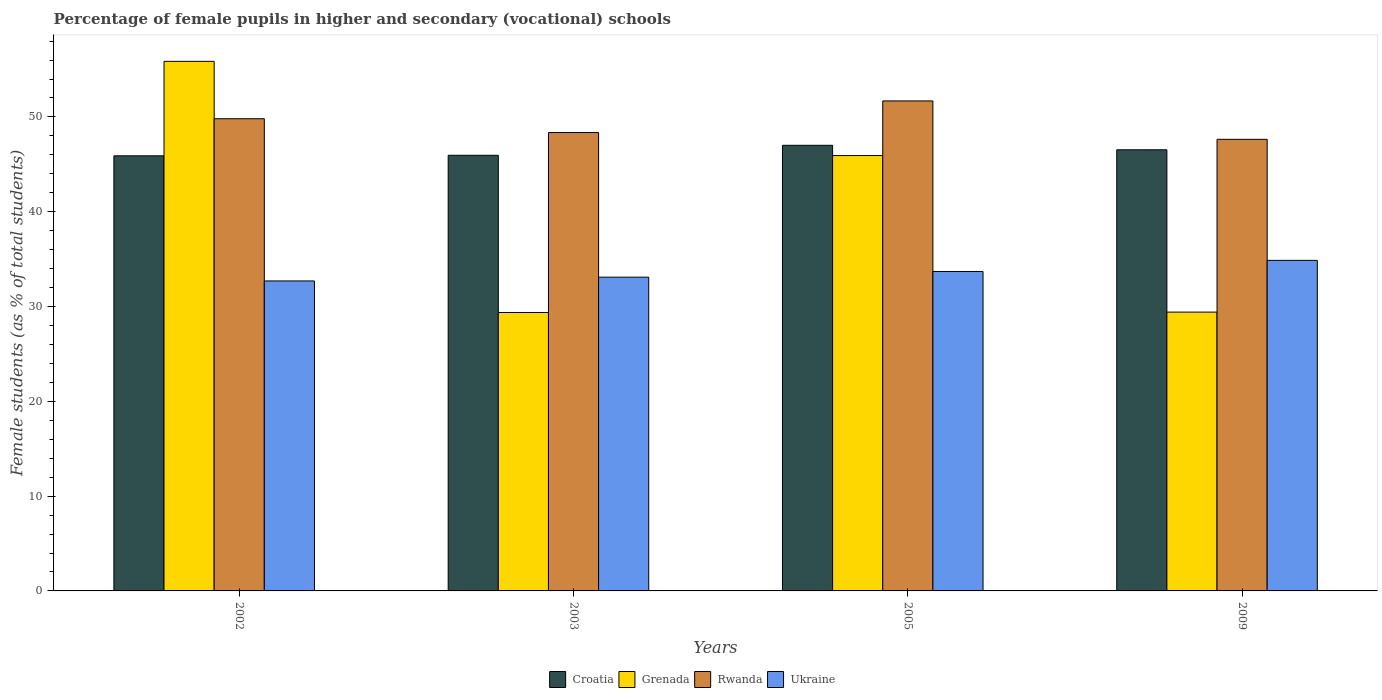How many groups of bars are there?
Provide a succinct answer. 4. Are the number of bars per tick equal to the number of legend labels?
Offer a terse response. Yes. Are the number of bars on each tick of the X-axis equal?
Offer a very short reply. Yes. How many bars are there on the 4th tick from the left?
Your response must be concise. 4. How many bars are there on the 4th tick from the right?
Your answer should be very brief. 4. In how many cases, is the number of bars for a given year not equal to the number of legend labels?
Offer a terse response. 0. What is the percentage of female pupils in higher and secondary schools in Rwanda in 2003?
Offer a very short reply. 48.35. Across all years, what is the maximum percentage of female pupils in higher and secondary schools in Grenada?
Make the answer very short. 55.87. Across all years, what is the minimum percentage of female pupils in higher and secondary schools in Rwanda?
Provide a short and direct response. 47.64. In which year was the percentage of female pupils in higher and secondary schools in Croatia maximum?
Your response must be concise. 2005. In which year was the percentage of female pupils in higher and secondary schools in Grenada minimum?
Provide a succinct answer. 2003. What is the total percentage of female pupils in higher and secondary schools in Croatia in the graph?
Offer a very short reply. 185.4. What is the difference between the percentage of female pupils in higher and secondary schools in Ukraine in 2002 and that in 2009?
Make the answer very short. -2.17. What is the difference between the percentage of female pupils in higher and secondary schools in Grenada in 2003 and the percentage of female pupils in higher and secondary schools in Croatia in 2009?
Provide a short and direct response. -17.16. What is the average percentage of female pupils in higher and secondary schools in Ukraine per year?
Provide a succinct answer. 33.59. In the year 2009, what is the difference between the percentage of female pupils in higher and secondary schools in Rwanda and percentage of female pupils in higher and secondary schools in Grenada?
Provide a short and direct response. 18.23. In how many years, is the percentage of female pupils in higher and secondary schools in Grenada greater than 50 %?
Keep it short and to the point. 1. What is the ratio of the percentage of female pupils in higher and secondary schools in Ukraine in 2003 to that in 2005?
Ensure brevity in your answer.  0.98. What is the difference between the highest and the second highest percentage of female pupils in higher and secondary schools in Grenada?
Provide a succinct answer. 9.94. What is the difference between the highest and the lowest percentage of female pupils in higher and secondary schools in Croatia?
Provide a succinct answer. 1.11. Is it the case that in every year, the sum of the percentage of female pupils in higher and secondary schools in Ukraine and percentage of female pupils in higher and secondary schools in Grenada is greater than the sum of percentage of female pupils in higher and secondary schools in Croatia and percentage of female pupils in higher and secondary schools in Rwanda?
Your answer should be compact. No. What does the 2nd bar from the left in 2005 represents?
Provide a short and direct response. Grenada. What does the 1st bar from the right in 2009 represents?
Give a very brief answer. Ukraine. Does the graph contain any zero values?
Your answer should be compact. No. How many legend labels are there?
Ensure brevity in your answer.  4. What is the title of the graph?
Your response must be concise. Percentage of female pupils in higher and secondary (vocational) schools. Does "Australia" appear as one of the legend labels in the graph?
Offer a very short reply. No. What is the label or title of the X-axis?
Keep it short and to the point. Years. What is the label or title of the Y-axis?
Ensure brevity in your answer.  Female students (as % of total students). What is the Female students (as % of total students) of Croatia in 2002?
Make the answer very short. 45.9. What is the Female students (as % of total students) of Grenada in 2002?
Provide a succinct answer. 55.87. What is the Female students (as % of total students) of Rwanda in 2002?
Offer a very short reply. 49.81. What is the Female students (as % of total students) of Ukraine in 2002?
Ensure brevity in your answer.  32.7. What is the Female students (as % of total students) in Croatia in 2003?
Offer a terse response. 45.96. What is the Female students (as % of total students) in Grenada in 2003?
Provide a succinct answer. 29.37. What is the Female students (as % of total students) of Rwanda in 2003?
Your answer should be compact. 48.35. What is the Female students (as % of total students) in Ukraine in 2003?
Keep it short and to the point. 33.1. What is the Female students (as % of total students) of Croatia in 2005?
Your response must be concise. 47.01. What is the Female students (as % of total students) of Grenada in 2005?
Offer a terse response. 45.93. What is the Female students (as % of total students) of Rwanda in 2005?
Provide a succinct answer. 51.69. What is the Female students (as % of total students) of Ukraine in 2005?
Your answer should be very brief. 33.7. What is the Female students (as % of total students) of Croatia in 2009?
Your answer should be compact. 46.54. What is the Female students (as % of total students) of Grenada in 2009?
Provide a succinct answer. 29.41. What is the Female students (as % of total students) in Rwanda in 2009?
Your answer should be very brief. 47.64. What is the Female students (as % of total students) in Ukraine in 2009?
Provide a succinct answer. 34.87. Across all years, what is the maximum Female students (as % of total students) of Croatia?
Give a very brief answer. 47.01. Across all years, what is the maximum Female students (as % of total students) of Grenada?
Ensure brevity in your answer.  55.87. Across all years, what is the maximum Female students (as % of total students) of Rwanda?
Provide a succinct answer. 51.69. Across all years, what is the maximum Female students (as % of total students) of Ukraine?
Your response must be concise. 34.87. Across all years, what is the minimum Female students (as % of total students) in Croatia?
Offer a terse response. 45.9. Across all years, what is the minimum Female students (as % of total students) in Grenada?
Your answer should be very brief. 29.37. Across all years, what is the minimum Female students (as % of total students) of Rwanda?
Give a very brief answer. 47.64. Across all years, what is the minimum Female students (as % of total students) in Ukraine?
Your answer should be compact. 32.7. What is the total Female students (as % of total students) of Croatia in the graph?
Your answer should be compact. 185.4. What is the total Female students (as % of total students) in Grenada in the graph?
Keep it short and to the point. 160.58. What is the total Female students (as % of total students) in Rwanda in the graph?
Make the answer very short. 197.5. What is the total Female students (as % of total students) in Ukraine in the graph?
Your response must be concise. 134.37. What is the difference between the Female students (as % of total students) of Croatia in 2002 and that in 2003?
Provide a succinct answer. -0.06. What is the difference between the Female students (as % of total students) in Grenada in 2002 and that in 2003?
Provide a succinct answer. 26.49. What is the difference between the Female students (as % of total students) of Rwanda in 2002 and that in 2003?
Provide a short and direct response. 1.46. What is the difference between the Female students (as % of total students) in Ukraine in 2002 and that in 2003?
Ensure brevity in your answer.  -0.4. What is the difference between the Female students (as % of total students) in Croatia in 2002 and that in 2005?
Your answer should be compact. -1.11. What is the difference between the Female students (as % of total students) in Grenada in 2002 and that in 2005?
Give a very brief answer. 9.94. What is the difference between the Female students (as % of total students) of Rwanda in 2002 and that in 2005?
Provide a succinct answer. -1.88. What is the difference between the Female students (as % of total students) in Ukraine in 2002 and that in 2005?
Offer a terse response. -1. What is the difference between the Female students (as % of total students) of Croatia in 2002 and that in 2009?
Your response must be concise. -0.64. What is the difference between the Female students (as % of total students) of Grenada in 2002 and that in 2009?
Your answer should be very brief. 26.45. What is the difference between the Female students (as % of total students) of Rwanda in 2002 and that in 2009?
Offer a terse response. 2.17. What is the difference between the Female students (as % of total students) in Ukraine in 2002 and that in 2009?
Your answer should be very brief. -2.17. What is the difference between the Female students (as % of total students) of Croatia in 2003 and that in 2005?
Offer a very short reply. -1.05. What is the difference between the Female students (as % of total students) in Grenada in 2003 and that in 2005?
Keep it short and to the point. -16.55. What is the difference between the Female students (as % of total students) in Rwanda in 2003 and that in 2005?
Offer a very short reply. -3.34. What is the difference between the Female students (as % of total students) of Ukraine in 2003 and that in 2005?
Offer a very short reply. -0.6. What is the difference between the Female students (as % of total students) in Croatia in 2003 and that in 2009?
Keep it short and to the point. -0.58. What is the difference between the Female students (as % of total students) in Grenada in 2003 and that in 2009?
Provide a succinct answer. -0.04. What is the difference between the Female students (as % of total students) in Rwanda in 2003 and that in 2009?
Give a very brief answer. 0.71. What is the difference between the Female students (as % of total students) in Ukraine in 2003 and that in 2009?
Offer a very short reply. -1.77. What is the difference between the Female students (as % of total students) of Croatia in 2005 and that in 2009?
Provide a succinct answer. 0.47. What is the difference between the Female students (as % of total students) in Grenada in 2005 and that in 2009?
Give a very brief answer. 16.51. What is the difference between the Female students (as % of total students) of Rwanda in 2005 and that in 2009?
Keep it short and to the point. 4.05. What is the difference between the Female students (as % of total students) of Ukraine in 2005 and that in 2009?
Give a very brief answer. -1.17. What is the difference between the Female students (as % of total students) of Croatia in 2002 and the Female students (as % of total students) of Grenada in 2003?
Your answer should be very brief. 16.53. What is the difference between the Female students (as % of total students) in Croatia in 2002 and the Female students (as % of total students) in Rwanda in 2003?
Ensure brevity in your answer.  -2.46. What is the difference between the Female students (as % of total students) in Croatia in 2002 and the Female students (as % of total students) in Ukraine in 2003?
Offer a terse response. 12.8. What is the difference between the Female students (as % of total students) of Grenada in 2002 and the Female students (as % of total students) of Rwanda in 2003?
Your answer should be very brief. 7.51. What is the difference between the Female students (as % of total students) of Grenada in 2002 and the Female students (as % of total students) of Ukraine in 2003?
Offer a terse response. 22.77. What is the difference between the Female students (as % of total students) of Rwanda in 2002 and the Female students (as % of total students) of Ukraine in 2003?
Give a very brief answer. 16.71. What is the difference between the Female students (as % of total students) in Croatia in 2002 and the Female students (as % of total students) in Grenada in 2005?
Keep it short and to the point. -0.03. What is the difference between the Female students (as % of total students) in Croatia in 2002 and the Female students (as % of total students) in Rwanda in 2005?
Give a very brief answer. -5.79. What is the difference between the Female students (as % of total students) of Croatia in 2002 and the Female students (as % of total students) of Ukraine in 2005?
Your response must be concise. 12.2. What is the difference between the Female students (as % of total students) of Grenada in 2002 and the Female students (as % of total students) of Rwanda in 2005?
Your response must be concise. 4.17. What is the difference between the Female students (as % of total students) of Grenada in 2002 and the Female students (as % of total students) of Ukraine in 2005?
Keep it short and to the point. 22.17. What is the difference between the Female students (as % of total students) in Rwanda in 2002 and the Female students (as % of total students) in Ukraine in 2005?
Your answer should be very brief. 16.11. What is the difference between the Female students (as % of total students) in Croatia in 2002 and the Female students (as % of total students) in Grenada in 2009?
Provide a succinct answer. 16.49. What is the difference between the Female students (as % of total students) in Croatia in 2002 and the Female students (as % of total students) in Rwanda in 2009?
Make the answer very short. -1.74. What is the difference between the Female students (as % of total students) of Croatia in 2002 and the Female students (as % of total students) of Ukraine in 2009?
Ensure brevity in your answer.  11.03. What is the difference between the Female students (as % of total students) in Grenada in 2002 and the Female students (as % of total students) in Rwanda in 2009?
Offer a very short reply. 8.23. What is the difference between the Female students (as % of total students) in Grenada in 2002 and the Female students (as % of total students) in Ukraine in 2009?
Keep it short and to the point. 20.99. What is the difference between the Female students (as % of total students) of Rwanda in 2002 and the Female students (as % of total students) of Ukraine in 2009?
Offer a terse response. 14.94. What is the difference between the Female students (as % of total students) in Croatia in 2003 and the Female students (as % of total students) in Grenada in 2005?
Keep it short and to the point. 0.03. What is the difference between the Female students (as % of total students) in Croatia in 2003 and the Female students (as % of total students) in Rwanda in 2005?
Offer a very short reply. -5.74. What is the difference between the Female students (as % of total students) in Croatia in 2003 and the Female students (as % of total students) in Ukraine in 2005?
Give a very brief answer. 12.26. What is the difference between the Female students (as % of total students) of Grenada in 2003 and the Female students (as % of total students) of Rwanda in 2005?
Give a very brief answer. -22.32. What is the difference between the Female students (as % of total students) in Grenada in 2003 and the Female students (as % of total students) in Ukraine in 2005?
Give a very brief answer. -4.33. What is the difference between the Female students (as % of total students) in Rwanda in 2003 and the Female students (as % of total students) in Ukraine in 2005?
Your answer should be very brief. 14.65. What is the difference between the Female students (as % of total students) in Croatia in 2003 and the Female students (as % of total students) in Grenada in 2009?
Offer a terse response. 16.54. What is the difference between the Female students (as % of total students) of Croatia in 2003 and the Female students (as % of total students) of Rwanda in 2009?
Ensure brevity in your answer.  -1.68. What is the difference between the Female students (as % of total students) in Croatia in 2003 and the Female students (as % of total students) in Ukraine in 2009?
Provide a short and direct response. 11.08. What is the difference between the Female students (as % of total students) of Grenada in 2003 and the Female students (as % of total students) of Rwanda in 2009?
Give a very brief answer. -18.27. What is the difference between the Female students (as % of total students) of Grenada in 2003 and the Female students (as % of total students) of Ukraine in 2009?
Offer a terse response. -5.5. What is the difference between the Female students (as % of total students) of Rwanda in 2003 and the Female students (as % of total students) of Ukraine in 2009?
Provide a short and direct response. 13.48. What is the difference between the Female students (as % of total students) in Croatia in 2005 and the Female students (as % of total students) in Grenada in 2009?
Provide a short and direct response. 17.6. What is the difference between the Female students (as % of total students) of Croatia in 2005 and the Female students (as % of total students) of Rwanda in 2009?
Offer a terse response. -0.63. What is the difference between the Female students (as % of total students) of Croatia in 2005 and the Female students (as % of total students) of Ukraine in 2009?
Your answer should be compact. 12.14. What is the difference between the Female students (as % of total students) of Grenada in 2005 and the Female students (as % of total students) of Rwanda in 2009?
Provide a short and direct response. -1.71. What is the difference between the Female students (as % of total students) in Grenada in 2005 and the Female students (as % of total students) in Ukraine in 2009?
Your answer should be compact. 11.05. What is the difference between the Female students (as % of total students) in Rwanda in 2005 and the Female students (as % of total students) in Ukraine in 2009?
Ensure brevity in your answer.  16.82. What is the average Female students (as % of total students) in Croatia per year?
Provide a short and direct response. 46.35. What is the average Female students (as % of total students) of Grenada per year?
Make the answer very short. 40.14. What is the average Female students (as % of total students) in Rwanda per year?
Provide a short and direct response. 49.38. What is the average Female students (as % of total students) of Ukraine per year?
Your answer should be very brief. 33.59. In the year 2002, what is the difference between the Female students (as % of total students) of Croatia and Female students (as % of total students) of Grenada?
Provide a short and direct response. -9.97. In the year 2002, what is the difference between the Female students (as % of total students) in Croatia and Female students (as % of total students) in Rwanda?
Provide a succinct answer. -3.91. In the year 2002, what is the difference between the Female students (as % of total students) of Croatia and Female students (as % of total students) of Ukraine?
Make the answer very short. 13.2. In the year 2002, what is the difference between the Female students (as % of total students) of Grenada and Female students (as % of total students) of Rwanda?
Offer a terse response. 6.05. In the year 2002, what is the difference between the Female students (as % of total students) in Grenada and Female students (as % of total students) in Ukraine?
Offer a very short reply. 23.17. In the year 2002, what is the difference between the Female students (as % of total students) in Rwanda and Female students (as % of total students) in Ukraine?
Provide a short and direct response. 17.11. In the year 2003, what is the difference between the Female students (as % of total students) in Croatia and Female students (as % of total students) in Grenada?
Your response must be concise. 16.58. In the year 2003, what is the difference between the Female students (as % of total students) of Croatia and Female students (as % of total students) of Rwanda?
Your response must be concise. -2.4. In the year 2003, what is the difference between the Female students (as % of total students) in Croatia and Female students (as % of total students) in Ukraine?
Your response must be concise. 12.86. In the year 2003, what is the difference between the Female students (as % of total students) of Grenada and Female students (as % of total students) of Rwanda?
Make the answer very short. -18.98. In the year 2003, what is the difference between the Female students (as % of total students) in Grenada and Female students (as % of total students) in Ukraine?
Offer a terse response. -3.73. In the year 2003, what is the difference between the Female students (as % of total students) of Rwanda and Female students (as % of total students) of Ukraine?
Ensure brevity in your answer.  15.26. In the year 2005, what is the difference between the Female students (as % of total students) of Croatia and Female students (as % of total students) of Grenada?
Ensure brevity in your answer.  1.08. In the year 2005, what is the difference between the Female students (as % of total students) of Croatia and Female students (as % of total students) of Rwanda?
Your answer should be compact. -4.68. In the year 2005, what is the difference between the Female students (as % of total students) of Croatia and Female students (as % of total students) of Ukraine?
Your answer should be very brief. 13.31. In the year 2005, what is the difference between the Female students (as % of total students) in Grenada and Female students (as % of total students) in Rwanda?
Your answer should be very brief. -5.77. In the year 2005, what is the difference between the Female students (as % of total students) of Grenada and Female students (as % of total students) of Ukraine?
Keep it short and to the point. 12.23. In the year 2005, what is the difference between the Female students (as % of total students) in Rwanda and Female students (as % of total students) in Ukraine?
Your answer should be compact. 17.99. In the year 2009, what is the difference between the Female students (as % of total students) in Croatia and Female students (as % of total students) in Grenada?
Make the answer very short. 17.12. In the year 2009, what is the difference between the Female students (as % of total students) in Croatia and Female students (as % of total students) in Rwanda?
Ensure brevity in your answer.  -1.1. In the year 2009, what is the difference between the Female students (as % of total students) in Croatia and Female students (as % of total students) in Ukraine?
Provide a succinct answer. 11.66. In the year 2009, what is the difference between the Female students (as % of total students) in Grenada and Female students (as % of total students) in Rwanda?
Your answer should be compact. -18.23. In the year 2009, what is the difference between the Female students (as % of total students) in Grenada and Female students (as % of total students) in Ukraine?
Offer a terse response. -5.46. In the year 2009, what is the difference between the Female students (as % of total students) in Rwanda and Female students (as % of total students) in Ukraine?
Your answer should be very brief. 12.77. What is the ratio of the Female students (as % of total students) of Grenada in 2002 to that in 2003?
Offer a terse response. 1.9. What is the ratio of the Female students (as % of total students) of Rwanda in 2002 to that in 2003?
Make the answer very short. 1.03. What is the ratio of the Female students (as % of total students) of Ukraine in 2002 to that in 2003?
Give a very brief answer. 0.99. What is the ratio of the Female students (as % of total students) in Croatia in 2002 to that in 2005?
Offer a terse response. 0.98. What is the ratio of the Female students (as % of total students) in Grenada in 2002 to that in 2005?
Provide a succinct answer. 1.22. What is the ratio of the Female students (as % of total students) in Rwanda in 2002 to that in 2005?
Keep it short and to the point. 0.96. What is the ratio of the Female students (as % of total students) in Ukraine in 2002 to that in 2005?
Your response must be concise. 0.97. What is the ratio of the Female students (as % of total students) of Croatia in 2002 to that in 2009?
Your answer should be very brief. 0.99. What is the ratio of the Female students (as % of total students) in Grenada in 2002 to that in 2009?
Provide a short and direct response. 1.9. What is the ratio of the Female students (as % of total students) in Rwanda in 2002 to that in 2009?
Make the answer very short. 1.05. What is the ratio of the Female students (as % of total students) in Ukraine in 2002 to that in 2009?
Give a very brief answer. 0.94. What is the ratio of the Female students (as % of total students) in Croatia in 2003 to that in 2005?
Provide a short and direct response. 0.98. What is the ratio of the Female students (as % of total students) of Grenada in 2003 to that in 2005?
Offer a very short reply. 0.64. What is the ratio of the Female students (as % of total students) in Rwanda in 2003 to that in 2005?
Provide a short and direct response. 0.94. What is the ratio of the Female students (as % of total students) of Ukraine in 2003 to that in 2005?
Your answer should be compact. 0.98. What is the ratio of the Female students (as % of total students) of Croatia in 2003 to that in 2009?
Your answer should be very brief. 0.99. What is the ratio of the Female students (as % of total students) in Grenada in 2003 to that in 2009?
Provide a short and direct response. 1. What is the ratio of the Female students (as % of total students) in Ukraine in 2003 to that in 2009?
Offer a terse response. 0.95. What is the ratio of the Female students (as % of total students) of Croatia in 2005 to that in 2009?
Make the answer very short. 1.01. What is the ratio of the Female students (as % of total students) in Grenada in 2005 to that in 2009?
Make the answer very short. 1.56. What is the ratio of the Female students (as % of total students) in Rwanda in 2005 to that in 2009?
Offer a terse response. 1.08. What is the ratio of the Female students (as % of total students) in Ukraine in 2005 to that in 2009?
Provide a succinct answer. 0.97. What is the difference between the highest and the second highest Female students (as % of total students) of Croatia?
Keep it short and to the point. 0.47. What is the difference between the highest and the second highest Female students (as % of total students) of Grenada?
Provide a short and direct response. 9.94. What is the difference between the highest and the second highest Female students (as % of total students) in Rwanda?
Your response must be concise. 1.88. What is the difference between the highest and the second highest Female students (as % of total students) of Ukraine?
Offer a terse response. 1.17. What is the difference between the highest and the lowest Female students (as % of total students) in Croatia?
Provide a short and direct response. 1.11. What is the difference between the highest and the lowest Female students (as % of total students) of Grenada?
Your response must be concise. 26.49. What is the difference between the highest and the lowest Female students (as % of total students) of Rwanda?
Keep it short and to the point. 4.05. What is the difference between the highest and the lowest Female students (as % of total students) in Ukraine?
Offer a terse response. 2.17. 